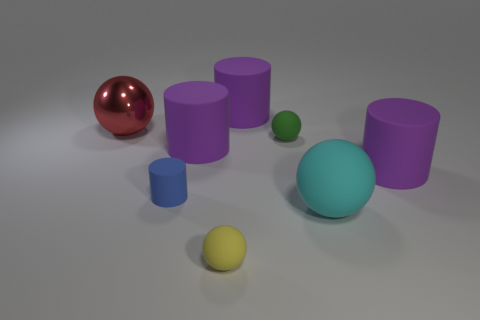Subtract all red balls. How many balls are left? 3 Subtract all red balls. How many purple cylinders are left? 3 Add 1 large gray metallic cylinders. How many objects exist? 9 Subtract all cyan spheres. How many spheres are left? 3 Subtract 1 cylinders. How many cylinders are left? 3 Subtract all red shiny spheres. Subtract all big cyan rubber spheres. How many objects are left? 6 Add 2 small cylinders. How many small cylinders are left? 3 Add 7 big cyan spheres. How many big cyan spheres exist? 8 Subtract 3 purple cylinders. How many objects are left? 5 Subtract all blue cylinders. Subtract all blue cubes. How many cylinders are left? 3 